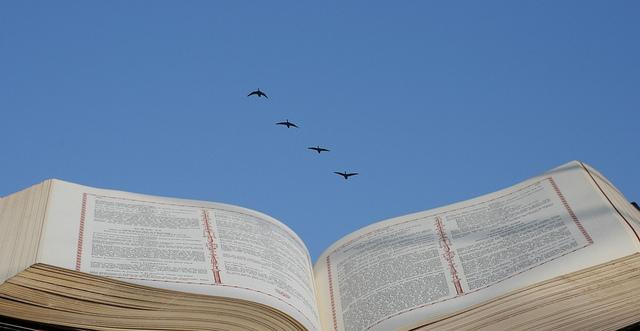Birds seen here are likely doing what? Please explain your reasoning. migrating. The birds are going to another place to rest. 